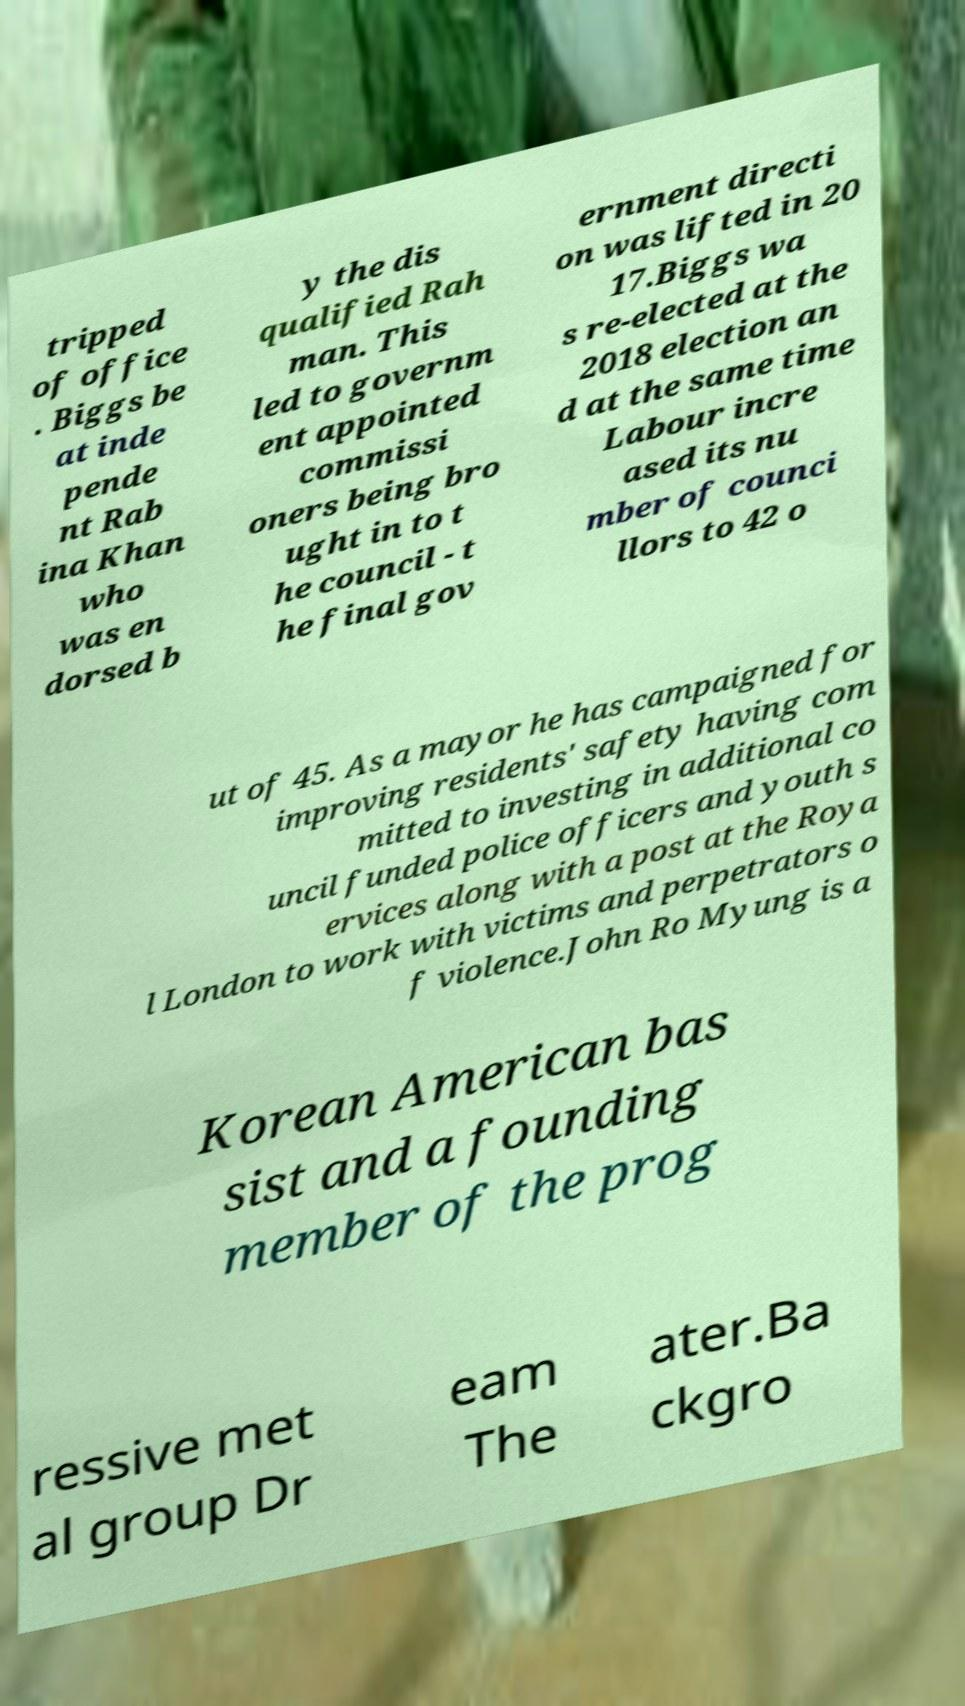There's text embedded in this image that I need extracted. Can you transcribe it verbatim? tripped of office . Biggs be at inde pende nt Rab ina Khan who was en dorsed b y the dis qualified Rah man. This led to governm ent appointed commissi oners being bro ught in to t he council - t he final gov ernment directi on was lifted in 20 17.Biggs wa s re-elected at the 2018 election an d at the same time Labour incre ased its nu mber of counci llors to 42 o ut of 45. As a mayor he has campaigned for improving residents' safety having com mitted to investing in additional co uncil funded police officers and youth s ervices along with a post at the Roya l London to work with victims and perpetrators o f violence.John Ro Myung is a Korean American bas sist and a founding member of the prog ressive met al group Dr eam The ater.Ba ckgro 